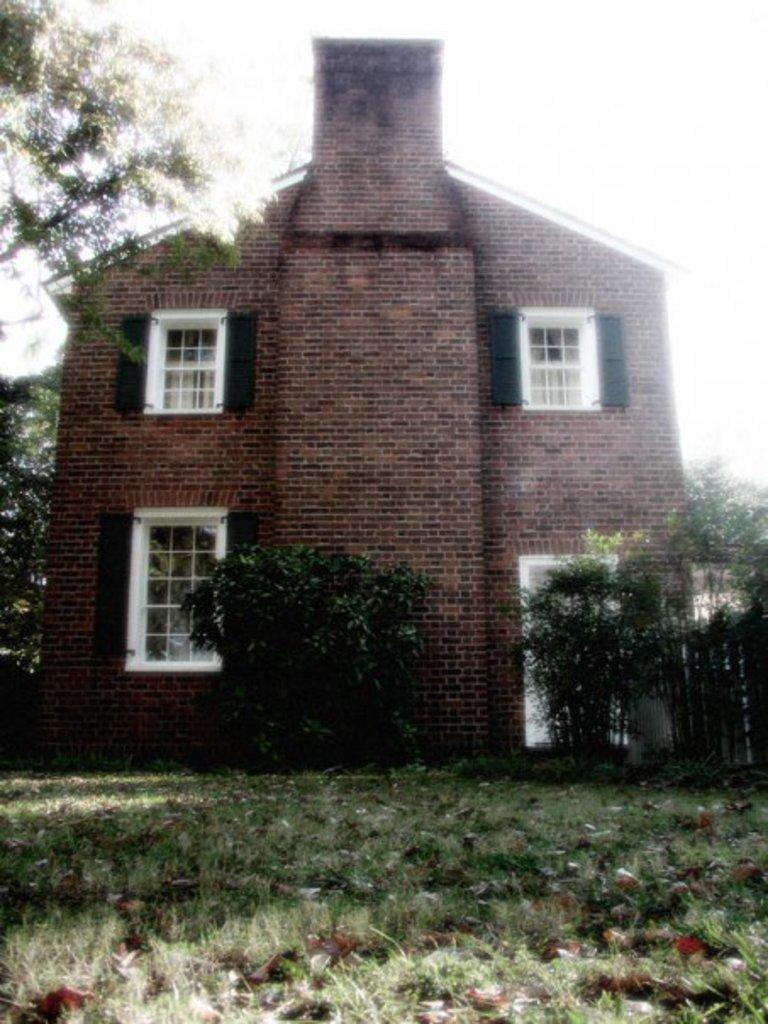What is the main structure in the image? There is a building in the center of the image. What type of vegetation can be seen at the bottom of the image? Grass is visible at the bottom of the image. What can be seen in the background of the image? There are trees and the sky visible in the background of the image. How many stamps are on the building in the image? There are no stamps present on the building in the image. What type of hand gesture can be seen in the image? There is no hand gesture visible in the image. 